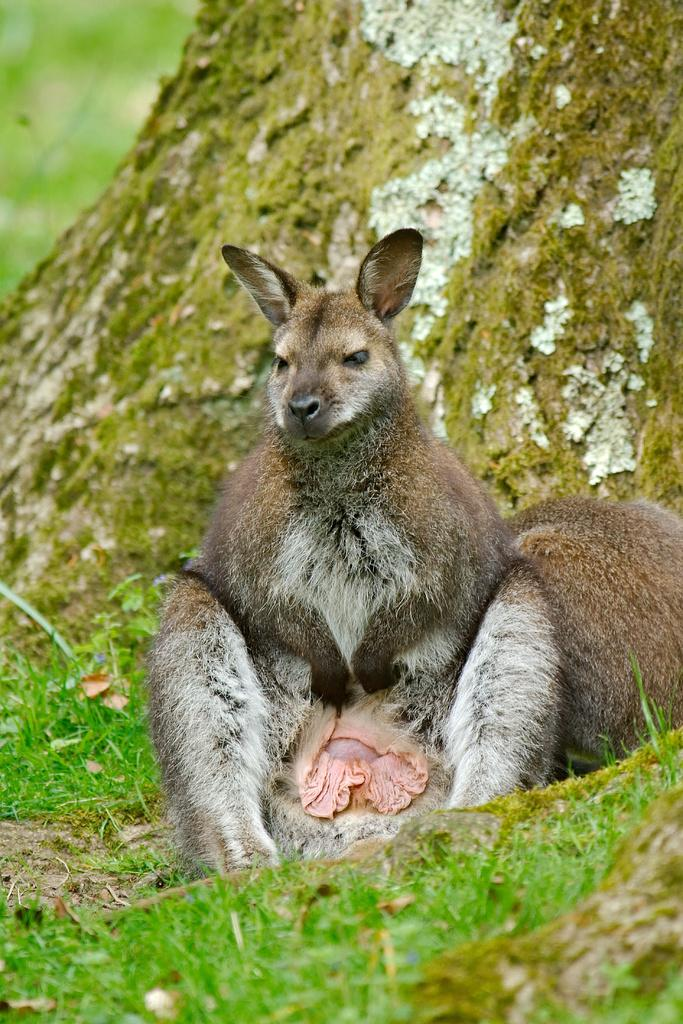What is the main subject in the center of the image? There is an animal in the center of the image. What type of natural environment is visible in the image? There is grass visible in the image. What part of a tree can be seen in the image? The bark of a tree is present in the image. How many boats are visible in the image? There are no boats present in the image. What type of laborer can be seen working in the image? There is no laborer present in the image. 